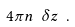Convert formula to latex. <formula><loc_0><loc_0><loc_500><loc_500>4 \pi n \ \delta z \ .</formula> 